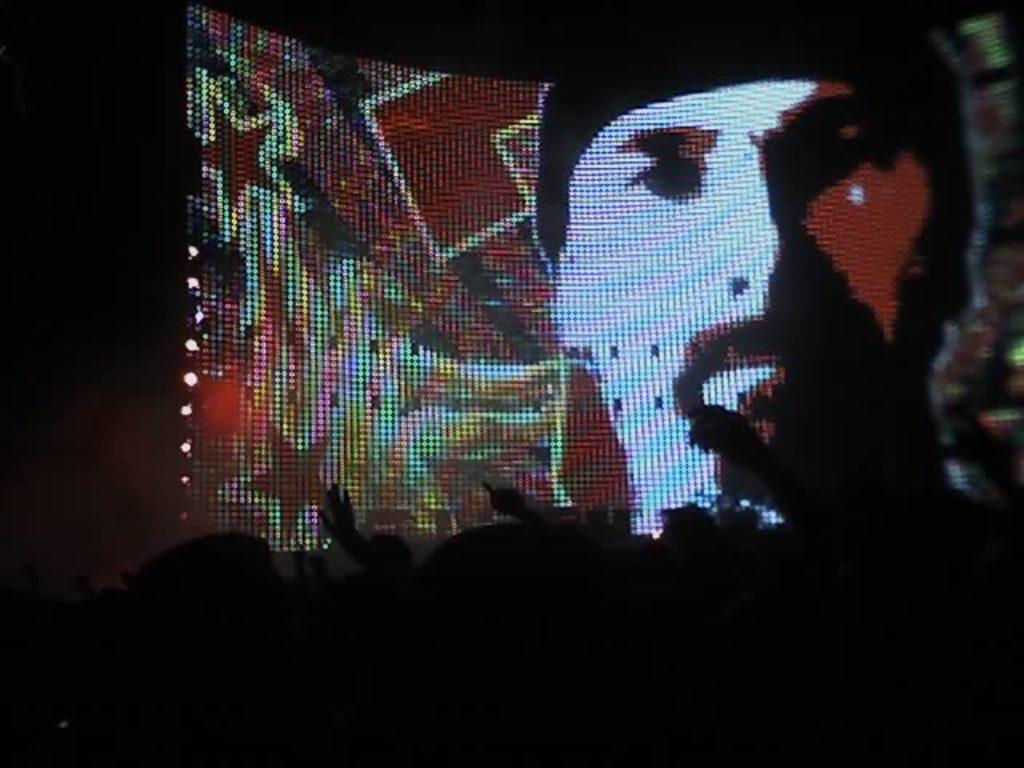In one or two sentences, can you explain what this image depicts? This picture is dark, we can see a screen, in this screen we can see a person face. 